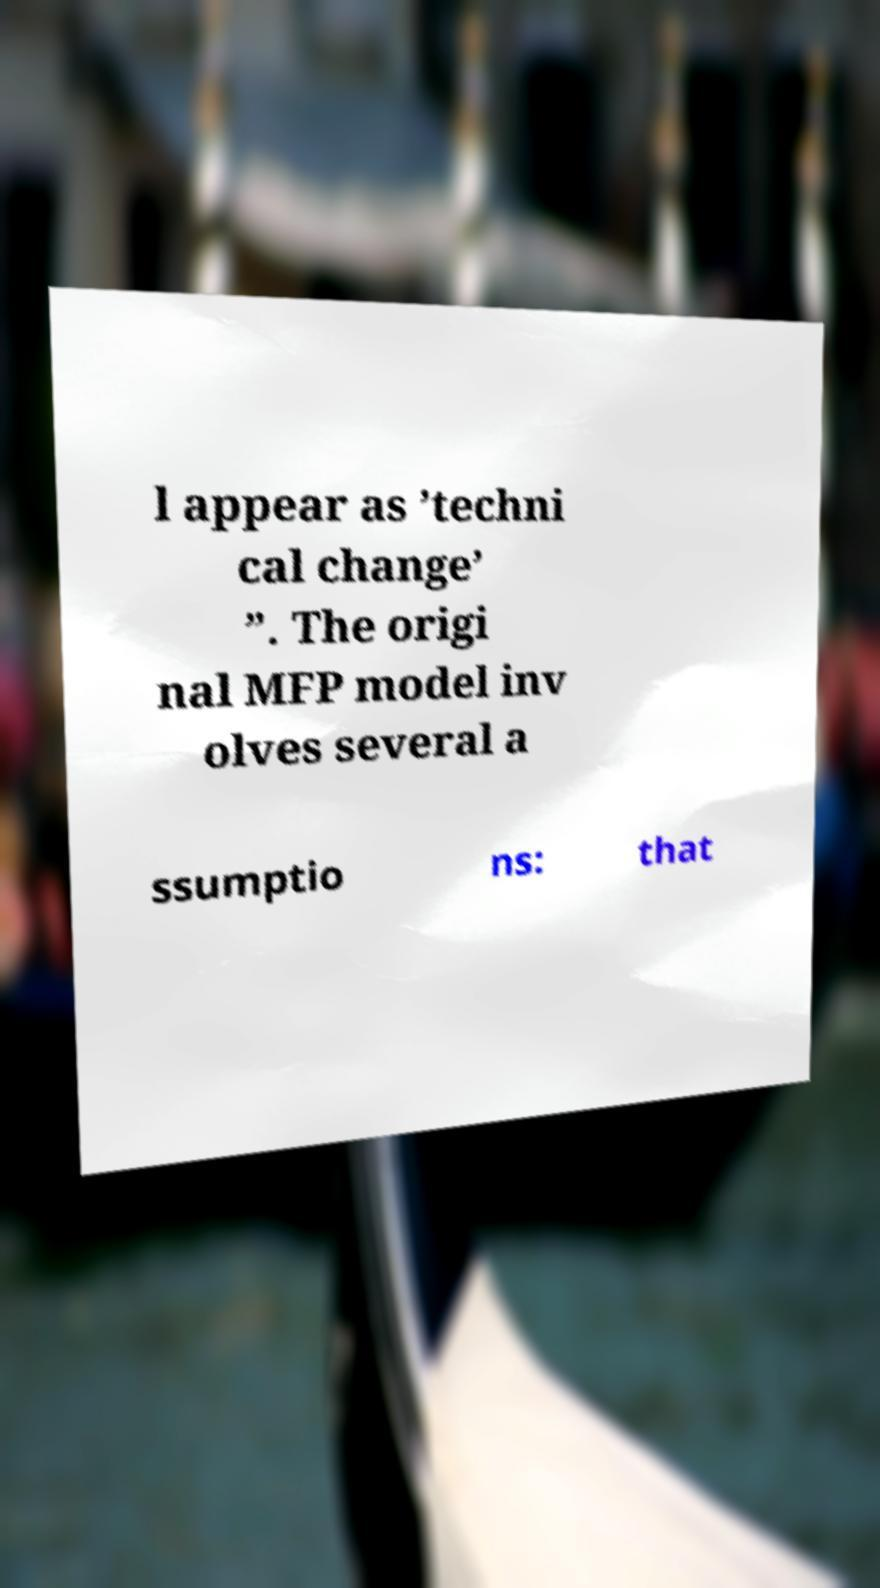Please read and relay the text visible in this image. What does it say? l appear as ’techni cal change’ ”. The origi nal MFP model inv olves several a ssumptio ns: that 